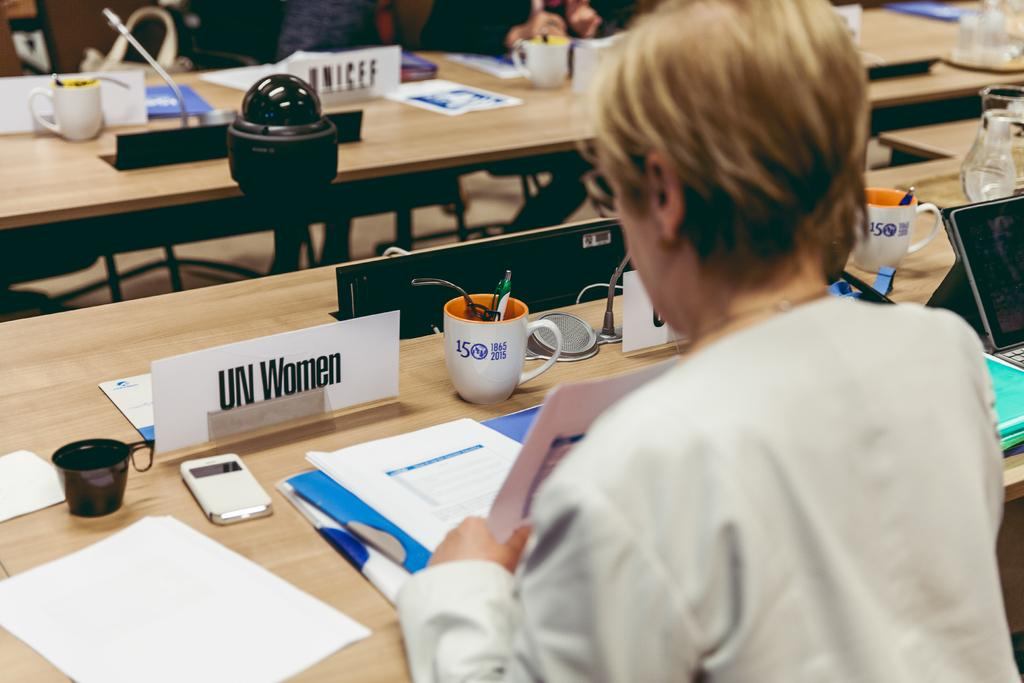What is the woman doing in the image? The woman is sitting on chairs near a table. What objects are on the table in the image? There are cups, a mobile phone, files, a laptop, and a name plate on the table. Can you describe the table setting in the image? The table has a variety of objects, including cups, a mobile phone, files, a laptop, and a name plate. What electronic device is present on the table? There is a laptop on the table. What type of skin is visible on the woman's hand in the image? There is no information about the woman's skin in the image, as it only shows her sitting on chairs and the objects on the table. 